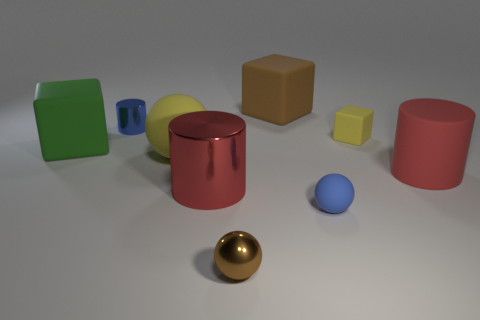Subtract all red cylinders. How many were subtracted if there are1red cylinders left? 1 Subtract all yellow matte cubes. How many cubes are left? 2 Subtract all blue cubes. How many red cylinders are left? 2 Add 1 yellow matte cubes. How many objects exist? 10 Subtract 1 cubes. How many cubes are left? 2 Subtract all cubes. How many objects are left? 6 Subtract all cyan blocks. Subtract all brown spheres. How many blocks are left? 3 Add 2 large green cubes. How many large green cubes are left? 3 Add 8 tiny metal cylinders. How many tiny metal cylinders exist? 9 Subtract 0 gray cylinders. How many objects are left? 9 